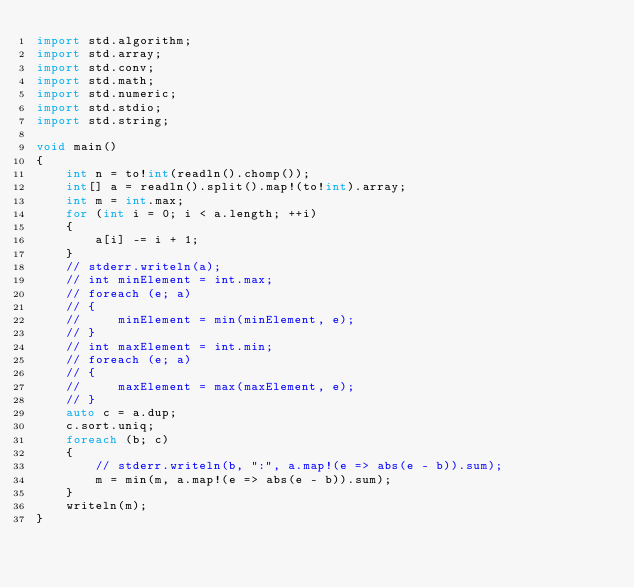Convert code to text. <code><loc_0><loc_0><loc_500><loc_500><_D_>import std.algorithm;
import std.array;
import std.conv;
import std.math;
import std.numeric;
import std.stdio;
import std.string;

void main()
{
    int n = to!int(readln().chomp());
    int[] a = readln().split().map!(to!int).array;
    int m = int.max;
    for (int i = 0; i < a.length; ++i)
    {
        a[i] -= i + 1;
    }
    // stderr.writeln(a);
    // int minElement = int.max;
    // foreach (e; a)
    // {
    //     minElement = min(minElement, e);
    // }
    // int maxElement = int.min;
    // foreach (e; a)
    // {
    //     maxElement = max(maxElement, e);
    // }
    auto c = a.dup;
    c.sort.uniq;
    foreach (b; c)
    {
        // stderr.writeln(b, ":", a.map!(e => abs(e - b)).sum);
        m = min(m, a.map!(e => abs(e - b)).sum);
    }
    writeln(m);
}
</code> 